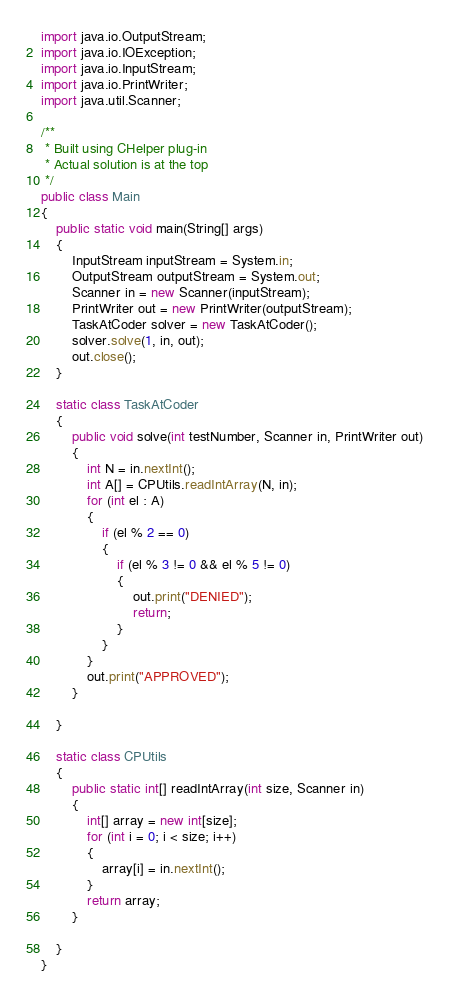Convert code to text. <code><loc_0><loc_0><loc_500><loc_500><_Java_>import java.io.OutputStream;
import java.io.IOException;
import java.io.InputStream;
import java.io.PrintWriter;
import java.util.Scanner;

/**
 * Built using CHelper plug-in
 * Actual solution is at the top
 */
public class Main
{
    public static void main(String[] args)
    {
        InputStream inputStream = System.in;
        OutputStream outputStream = System.out;
        Scanner in = new Scanner(inputStream);
        PrintWriter out = new PrintWriter(outputStream);
        TaskAtCoder solver = new TaskAtCoder();
        solver.solve(1, in, out);
        out.close();
    }

    static class TaskAtCoder
    {
        public void solve(int testNumber, Scanner in, PrintWriter out)
        {
            int N = in.nextInt();
            int A[] = CPUtils.readIntArray(N, in);
            for (int el : A)
            {
                if (el % 2 == 0)
                {
                    if (el % 3 != 0 && el % 5 != 0)
                    {
                        out.print("DENIED");
                        return;
                    }
                }
            }
            out.print("APPROVED");
        }

    }

    static class CPUtils
    {
        public static int[] readIntArray(int size, Scanner in)
        {
            int[] array = new int[size];
            for (int i = 0; i < size; i++)
            {
                array[i] = in.nextInt();
            }
            return array;
        }

    }
}

</code> 